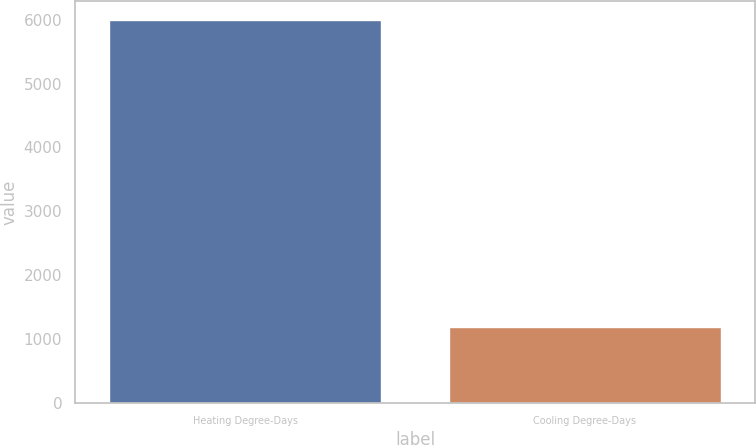Convert chart. <chart><loc_0><loc_0><loc_500><loc_500><bar_chart><fcel>Heating Degree-Days<fcel>Cooling Degree-Days<nl><fcel>5991<fcel>1181<nl></chart> 